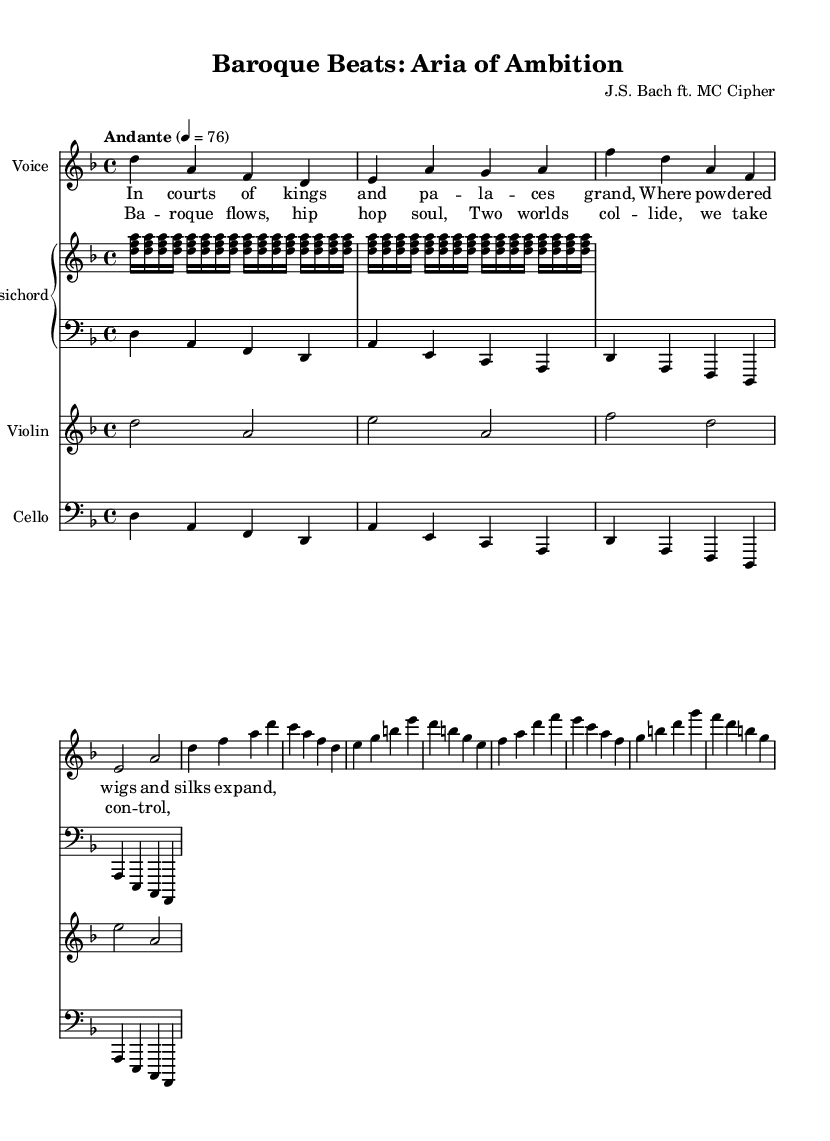What is the key signature of this music? The music is written in D minor, which has one flat (B flat). This can be determined by looking for the key signature at the beginning of the staff, where the flat indicates D minor.
Answer: D minor What is the time signature of the piece? The time signature is 4/4, which indicates there are four beats in each measure and the quarter note gets one beat. This is evident from the symbol shown at the beginning of the piece.
Answer: 4/4 What is the tempo marking of the music? The tempo marking is "Andante," which indicates a moderately slow tempo. This is noted under the tempo instruction at the beginning of the score.
Answer: Andante How many measures are in the verse section? The verse section consists of 8 measures, which can be counted by looking at the groupings of vertical lines (bar lines) separating measures.
Answer: 8 measures What type of vocals are indicated for this aria? The vocal part is indicated for soprano voice, which is shown by the designation on the staff specifically labeled "Voice" and "soprano."
Answer: Soprano Which instruments accompany the vocals in this piece? The vocals are accompanied by a harpsichord, violin, and cello, which are labeled on their respective staves in the score.
Answer: Harpsichord, violin, cello What is the theme of the chorus lyrics? The chorus lyrics convey a blending of Baroque and hip hop elements, suggesting a fusion of styles and control over the music's direction. This can be deduced from the lyrics themselves.
Answer: Fusion of styles 